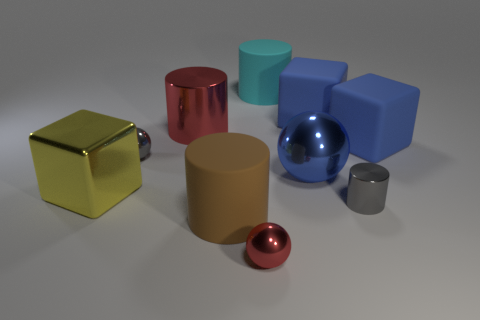Subtract all cylinders. How many objects are left? 6 Subtract all small gray metal things. Subtract all blue metallic objects. How many objects are left? 7 Add 7 big blue rubber things. How many big blue rubber things are left? 9 Add 4 tiny metal balls. How many tiny metal balls exist? 6 Subtract 1 blue balls. How many objects are left? 9 